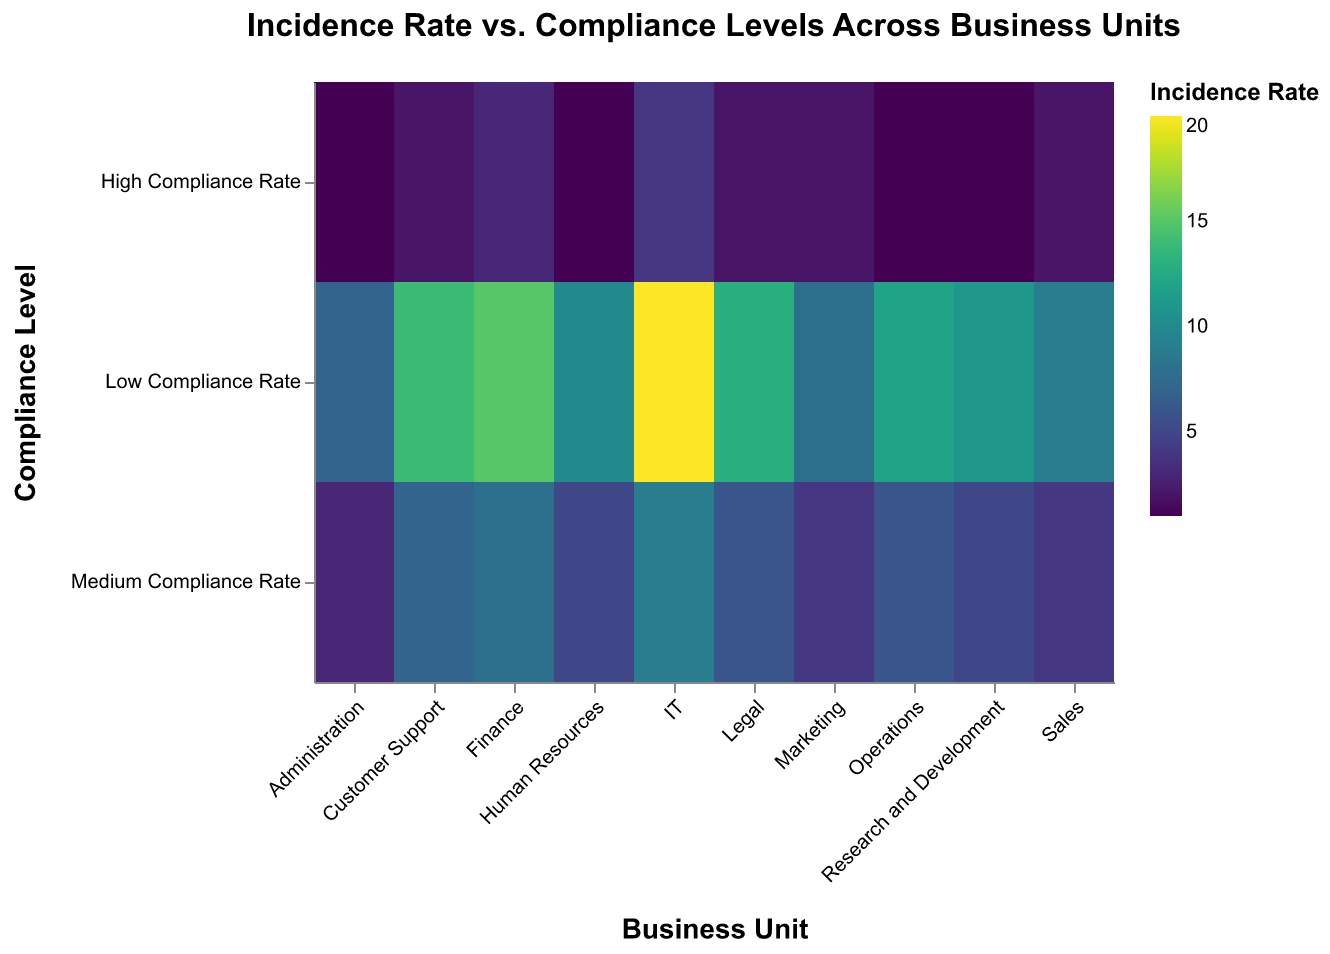What business unit has the highest incidence rate in the low compliance category? First, identify the category 'Low Compliance Rate' on the Y-axis. Then, find the business units within this category and compare their values. IT has the highest incidence rate with a value of 20.
Answer: IT What is the incidence rate for the Finance unit with high compliance? Locate the 'Finance' business unit on the X-axis and the 'High Compliance Rate' category on the Y-axis. The intersection gives the incidence rate of 3.
Answer: 3 Which business unit has the lowest overall incidence rate in the high compliance category? Identify the 'High Compliance Rate' on the Y-axis and look for the business unit with the lowest value among all business units in this category. Several units (HR, Operations, R&D, Administration) report the same lowest incidence rate, which is 1.
Answer: HR, Operations, R&D, Administration What's the difference in incidence rate between IT and Marketing during low compliance? Find the 'Low Compliance Rate' row and locate the values for IT (20) and Marketing (8). Subtract the Marketing value from the IT value: 20 - 8 = 12.
Answer: 12 Which compliance level has the least variance in incidence rates across all business units? Examine the range of values for each compliance level across all business units. The 'High Compliance Rate' category has the smallest range; values stretch from 1 to 4.
Answer: High Compliance Rate What is the total incidence rate across all compliance levels for the Customer Support unit? Add the values under Customer Support for all compliance levels: 14 (Low) + 7 (Medium) + 2 (High) = 23.
Answer: 23 How does the compliance level correlate with the incidence rate for the Finance unit? Compare the Finance unit's values across different compliance levels: Low (15), Medium (8), High (3). There's a decreasing trend in incidence rate as compliance improves.
Answer: Decreasing trend Which business unit exhibits the most significant improvement in incidence rate from low to high compliance levels? Calculate the difference for each business unit between their low and high compliance values. IT shows the largest improvement, dropping from 20 (Low) to 4 (High), a difference of 16.
Answer: IT Are there any business units that have the same incidence rate for medium compliance? Check the values in the 'Medium Compliance Rate' row for duplicates. HR and R&D both report an incidence rate of 5.
Answer: HR and R&D 